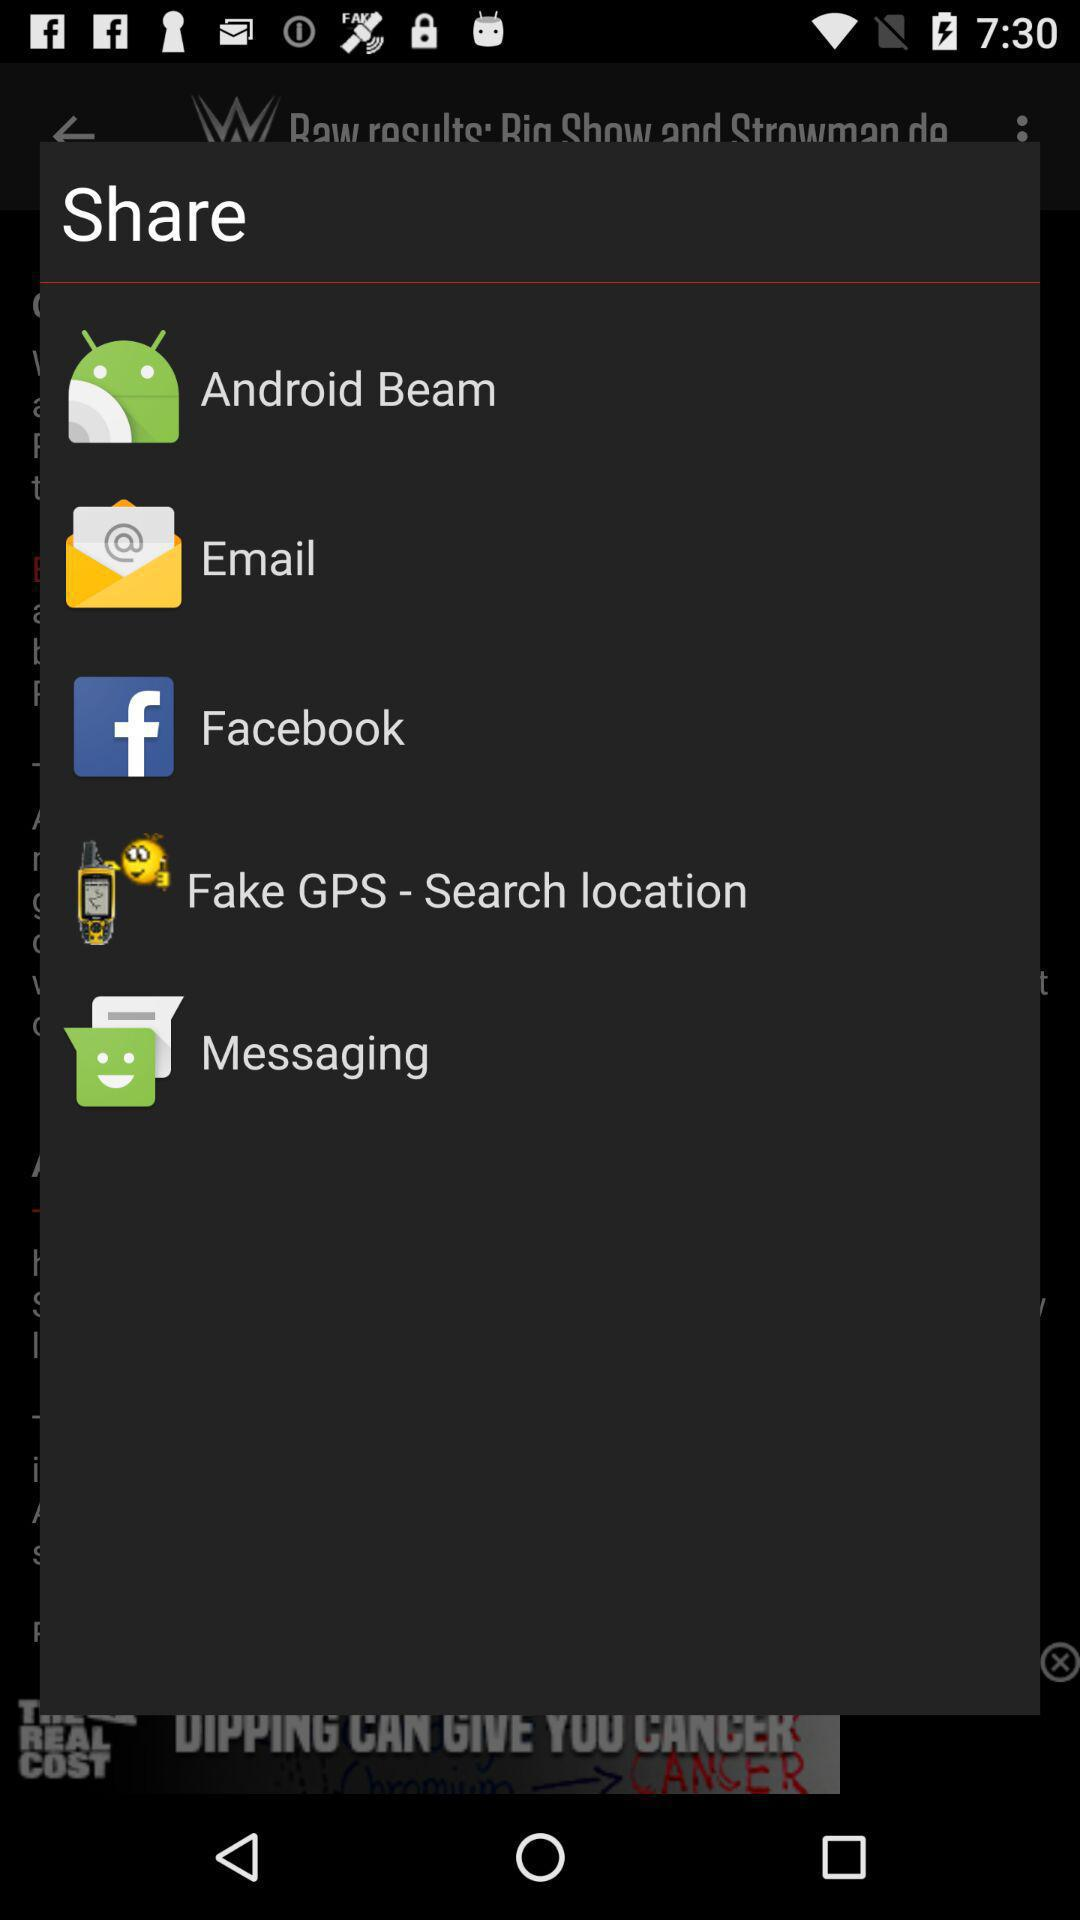What is the version of this application?
When the provided information is insufficient, respond with <no answer>. <no answer> 